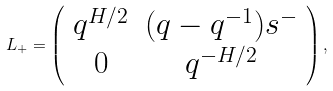Convert formula to latex. <formula><loc_0><loc_0><loc_500><loc_500>L _ { + } = \left ( \begin{array} { c c } q ^ { H / 2 } & ( q - q ^ { - 1 } ) s ^ { - } \\ 0 & q ^ { - H / 2 } \end{array} \right ) ,</formula> 